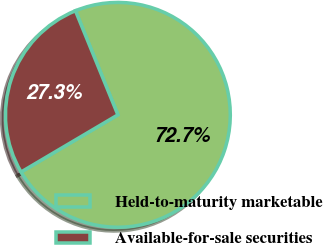<chart> <loc_0><loc_0><loc_500><loc_500><pie_chart><fcel>Held-to-maturity marketable<fcel>Available-for-sale securities<nl><fcel>72.67%<fcel>27.33%<nl></chart> 